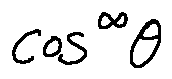<formula> <loc_0><loc_0><loc_500><loc_500>\cos ^ { \infty } \theta</formula> 